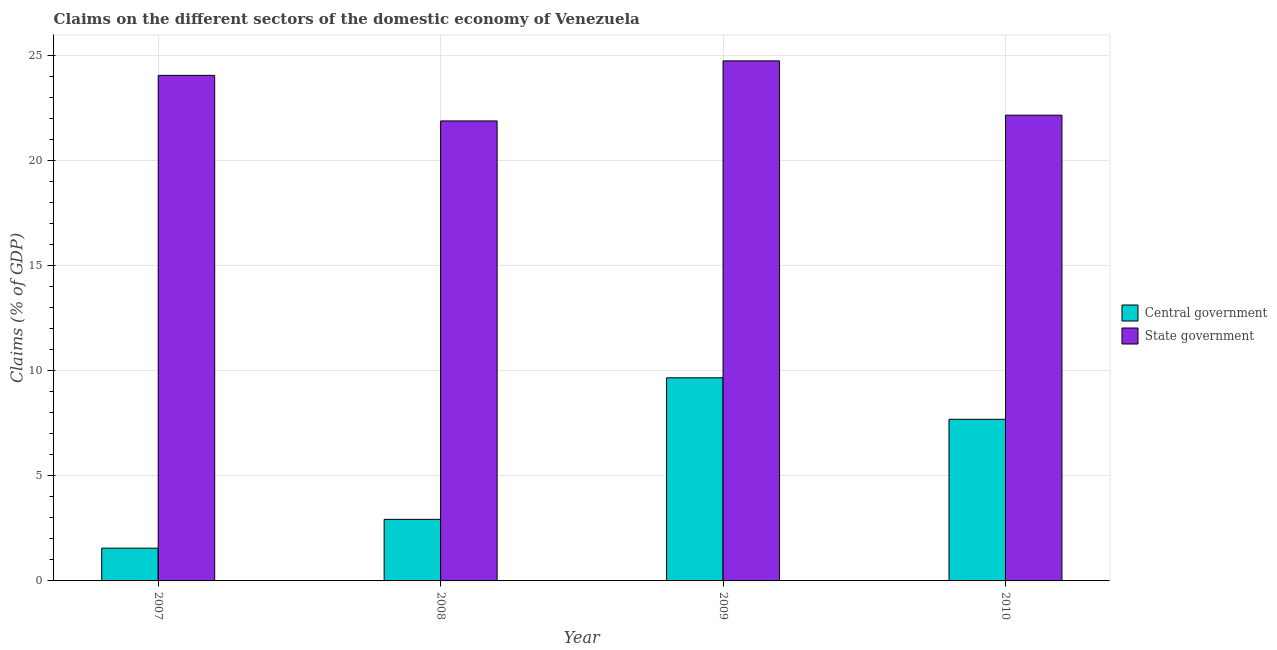Are the number of bars per tick equal to the number of legend labels?
Ensure brevity in your answer.  Yes. What is the label of the 3rd group of bars from the left?
Your answer should be compact. 2009. In how many cases, is the number of bars for a given year not equal to the number of legend labels?
Offer a terse response. 0. What is the claims on central government in 2009?
Your answer should be very brief. 9.67. Across all years, what is the maximum claims on state government?
Keep it short and to the point. 24.76. Across all years, what is the minimum claims on central government?
Provide a succinct answer. 1.56. What is the total claims on central government in the graph?
Ensure brevity in your answer.  21.86. What is the difference between the claims on state government in 2008 and that in 2009?
Provide a short and direct response. -2.86. What is the difference between the claims on state government in 2009 and the claims on central government in 2010?
Ensure brevity in your answer.  2.59. What is the average claims on central government per year?
Your answer should be compact. 5.46. In the year 2010, what is the difference between the claims on state government and claims on central government?
Keep it short and to the point. 0. What is the ratio of the claims on central government in 2007 to that in 2010?
Give a very brief answer. 0.2. Is the claims on state government in 2009 less than that in 2010?
Provide a succinct answer. No. Is the difference between the claims on central government in 2007 and 2008 greater than the difference between the claims on state government in 2007 and 2008?
Your answer should be very brief. No. What is the difference between the highest and the second highest claims on state government?
Offer a terse response. 0.69. What is the difference between the highest and the lowest claims on central government?
Make the answer very short. 8.11. Is the sum of the claims on central government in 2008 and 2009 greater than the maximum claims on state government across all years?
Provide a short and direct response. Yes. What does the 1st bar from the left in 2010 represents?
Offer a very short reply. Central government. What does the 2nd bar from the right in 2008 represents?
Offer a very short reply. Central government. How many bars are there?
Offer a terse response. 8. Are all the bars in the graph horizontal?
Keep it short and to the point. No. What is the difference between two consecutive major ticks on the Y-axis?
Offer a terse response. 5. How many legend labels are there?
Your response must be concise. 2. What is the title of the graph?
Keep it short and to the point. Claims on the different sectors of the domestic economy of Venezuela. What is the label or title of the Y-axis?
Offer a very short reply. Claims (% of GDP). What is the Claims (% of GDP) in Central government in 2007?
Provide a short and direct response. 1.56. What is the Claims (% of GDP) in State government in 2007?
Your response must be concise. 24.07. What is the Claims (% of GDP) in Central government in 2008?
Your answer should be compact. 2.93. What is the Claims (% of GDP) of State government in 2008?
Offer a terse response. 21.9. What is the Claims (% of GDP) in Central government in 2009?
Offer a terse response. 9.67. What is the Claims (% of GDP) of State government in 2009?
Provide a succinct answer. 24.76. What is the Claims (% of GDP) in Central government in 2010?
Provide a short and direct response. 7.7. What is the Claims (% of GDP) in State government in 2010?
Keep it short and to the point. 22.17. Across all years, what is the maximum Claims (% of GDP) in Central government?
Your answer should be compact. 9.67. Across all years, what is the maximum Claims (% of GDP) of State government?
Make the answer very short. 24.76. Across all years, what is the minimum Claims (% of GDP) of Central government?
Give a very brief answer. 1.56. Across all years, what is the minimum Claims (% of GDP) in State government?
Give a very brief answer. 21.9. What is the total Claims (% of GDP) of Central government in the graph?
Keep it short and to the point. 21.86. What is the total Claims (% of GDP) in State government in the graph?
Ensure brevity in your answer.  92.9. What is the difference between the Claims (% of GDP) of Central government in 2007 and that in 2008?
Your response must be concise. -1.37. What is the difference between the Claims (% of GDP) in State government in 2007 and that in 2008?
Your answer should be compact. 2.17. What is the difference between the Claims (% of GDP) in Central government in 2007 and that in 2009?
Your response must be concise. -8.11. What is the difference between the Claims (% of GDP) in State government in 2007 and that in 2009?
Offer a terse response. -0.69. What is the difference between the Claims (% of GDP) of Central government in 2007 and that in 2010?
Keep it short and to the point. -6.14. What is the difference between the Claims (% of GDP) of State government in 2007 and that in 2010?
Offer a terse response. 1.9. What is the difference between the Claims (% of GDP) in Central government in 2008 and that in 2009?
Make the answer very short. -6.74. What is the difference between the Claims (% of GDP) of State government in 2008 and that in 2009?
Ensure brevity in your answer.  -2.86. What is the difference between the Claims (% of GDP) of Central government in 2008 and that in 2010?
Offer a very short reply. -4.76. What is the difference between the Claims (% of GDP) in State government in 2008 and that in 2010?
Provide a short and direct response. -0.27. What is the difference between the Claims (% of GDP) of Central government in 2009 and that in 2010?
Provide a short and direct response. 1.98. What is the difference between the Claims (% of GDP) of State government in 2009 and that in 2010?
Ensure brevity in your answer.  2.59. What is the difference between the Claims (% of GDP) of Central government in 2007 and the Claims (% of GDP) of State government in 2008?
Offer a very short reply. -20.34. What is the difference between the Claims (% of GDP) of Central government in 2007 and the Claims (% of GDP) of State government in 2009?
Keep it short and to the point. -23.2. What is the difference between the Claims (% of GDP) in Central government in 2007 and the Claims (% of GDP) in State government in 2010?
Offer a very short reply. -20.61. What is the difference between the Claims (% of GDP) of Central government in 2008 and the Claims (% of GDP) of State government in 2009?
Ensure brevity in your answer.  -21.83. What is the difference between the Claims (% of GDP) of Central government in 2008 and the Claims (% of GDP) of State government in 2010?
Your response must be concise. -19.24. What is the difference between the Claims (% of GDP) of Central government in 2009 and the Claims (% of GDP) of State government in 2010?
Your response must be concise. -12.5. What is the average Claims (% of GDP) of Central government per year?
Provide a short and direct response. 5.46. What is the average Claims (% of GDP) in State government per year?
Your response must be concise. 23.23. In the year 2007, what is the difference between the Claims (% of GDP) of Central government and Claims (% of GDP) of State government?
Provide a succinct answer. -22.51. In the year 2008, what is the difference between the Claims (% of GDP) of Central government and Claims (% of GDP) of State government?
Provide a short and direct response. -18.97. In the year 2009, what is the difference between the Claims (% of GDP) in Central government and Claims (% of GDP) in State government?
Provide a succinct answer. -15.09. In the year 2010, what is the difference between the Claims (% of GDP) of Central government and Claims (% of GDP) of State government?
Give a very brief answer. -14.48. What is the ratio of the Claims (% of GDP) in Central government in 2007 to that in 2008?
Provide a succinct answer. 0.53. What is the ratio of the Claims (% of GDP) of State government in 2007 to that in 2008?
Offer a very short reply. 1.1. What is the ratio of the Claims (% of GDP) of Central government in 2007 to that in 2009?
Your answer should be compact. 0.16. What is the ratio of the Claims (% of GDP) of State government in 2007 to that in 2009?
Your answer should be compact. 0.97. What is the ratio of the Claims (% of GDP) of Central government in 2007 to that in 2010?
Your answer should be compact. 0.2. What is the ratio of the Claims (% of GDP) in State government in 2007 to that in 2010?
Your response must be concise. 1.09. What is the ratio of the Claims (% of GDP) in Central government in 2008 to that in 2009?
Ensure brevity in your answer.  0.3. What is the ratio of the Claims (% of GDP) of State government in 2008 to that in 2009?
Offer a very short reply. 0.88. What is the ratio of the Claims (% of GDP) of Central government in 2008 to that in 2010?
Your response must be concise. 0.38. What is the ratio of the Claims (% of GDP) of State government in 2008 to that in 2010?
Offer a very short reply. 0.99. What is the ratio of the Claims (% of GDP) of Central government in 2009 to that in 2010?
Make the answer very short. 1.26. What is the ratio of the Claims (% of GDP) of State government in 2009 to that in 2010?
Ensure brevity in your answer.  1.12. What is the difference between the highest and the second highest Claims (% of GDP) of Central government?
Offer a terse response. 1.98. What is the difference between the highest and the second highest Claims (% of GDP) of State government?
Provide a short and direct response. 0.69. What is the difference between the highest and the lowest Claims (% of GDP) of Central government?
Provide a short and direct response. 8.11. What is the difference between the highest and the lowest Claims (% of GDP) in State government?
Make the answer very short. 2.86. 